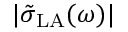Convert formula to latex. <formula><loc_0><loc_0><loc_500><loc_500>| \tilde { \sigma } _ { L A } ( \omega ) |</formula> 